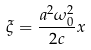<formula> <loc_0><loc_0><loc_500><loc_500>\xi = \frac { a ^ { 2 } \omega _ { 0 } ^ { 2 } } { 2 c } x</formula> 